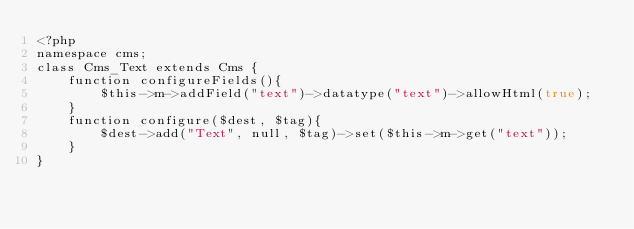<code> <loc_0><loc_0><loc_500><loc_500><_PHP_><?php
namespace cms;
class Cms_Text extends Cms {
    function configureFields(){
        $this->m->addField("text")->datatype("text")->allowHtml(true);
    }
    function configure($dest, $tag){
        $dest->add("Text", null, $tag)->set($this->m->get("text"));
    }
}
</code> 